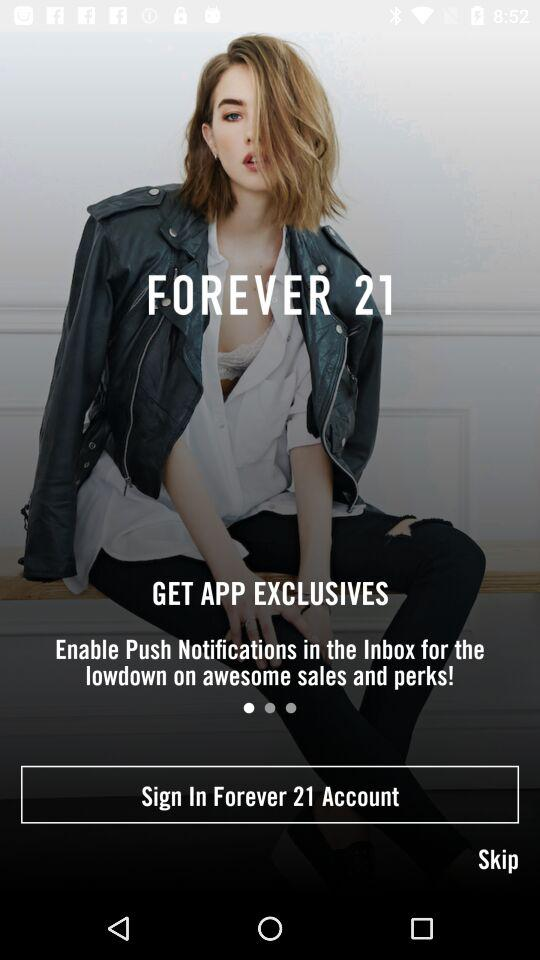What is the application name? The application name is "FOREVER 21". 